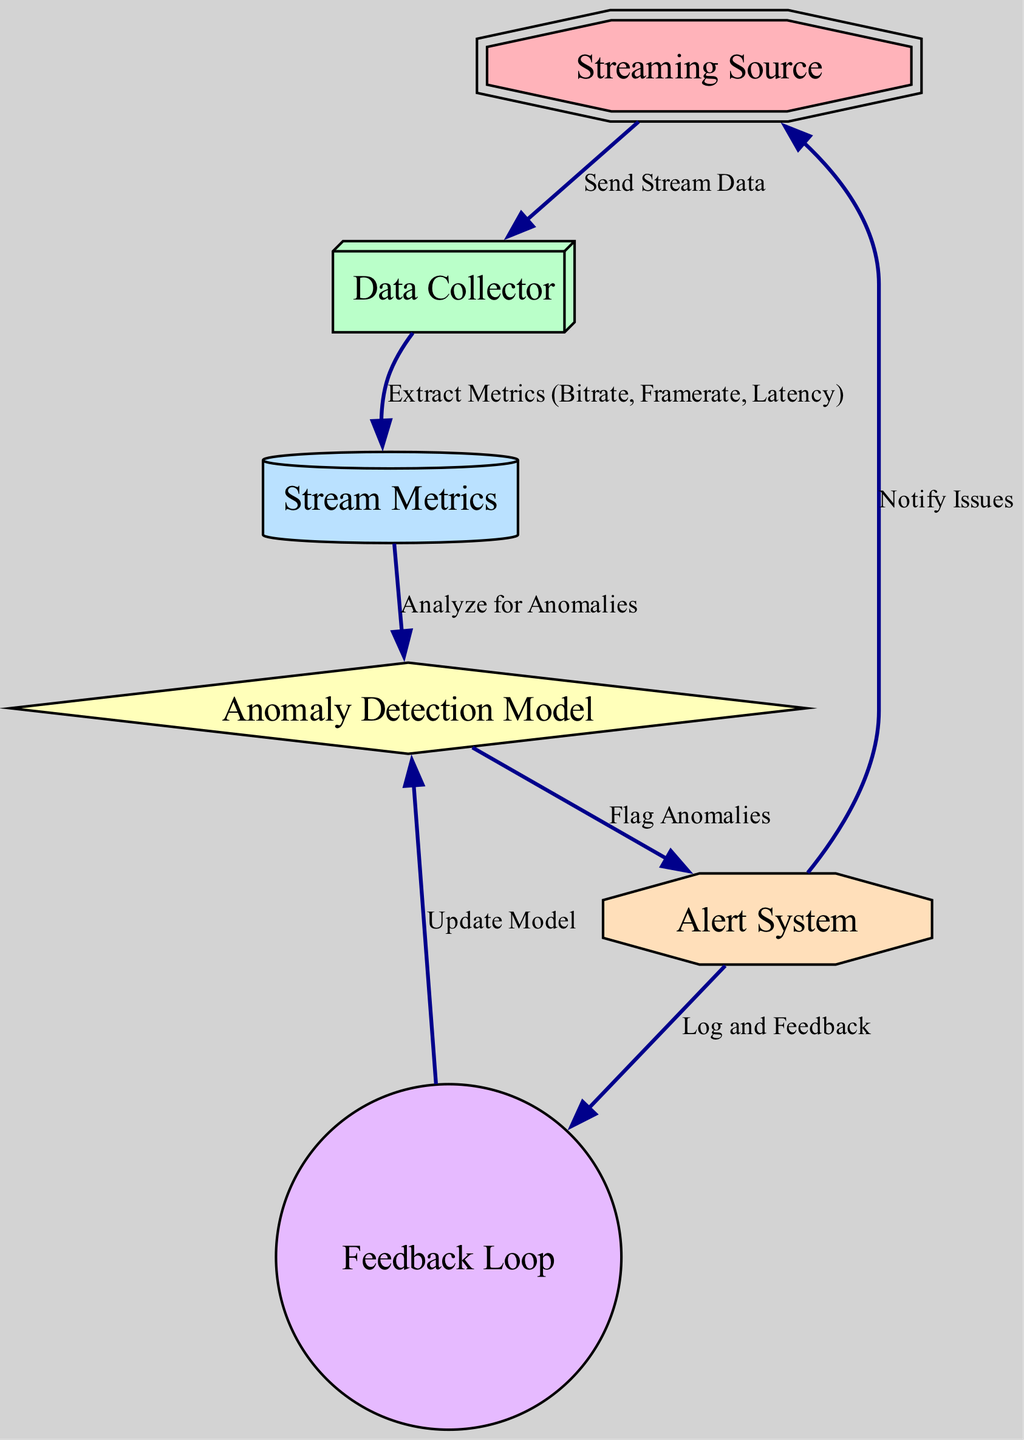What is the first node in the diagram? The first node, indicating the starting point of the process, is labeled "Streaming Source." This can be identified by locating the topmost node in the diagram layout.
Answer: Streaming Source How many nodes are present in the diagram? By counting all individual nodes listed in the diagram, we find six distinct nodes: "Streaming Source," "Data Collector," "Stream Metrics," "Anomaly Detection Model," "Alert System," and "Feedback Loop."
Answer: 6 What label is assigned to the second node? The second node is labeled "Data Collector." This can be determined by sequentially identifying the nodes based on their order in the diagram.
Answer: Data Collector Which node sends stream data? The node that sends stream data, indicated by the edge, is the "Streaming Source." This node has a direct outgoing edge labeled "Send Stream Data" pointing to the "Data Collector."
Answer: Streaming Source What is the final destination node for alerts? The final destination for alerts in the diagram is the "Streaming Source." This can be deduced from the outgoing edge from the "Alert System" node, which is labeled "Notify Issues" and points back to the "Streaming Source."
Answer: Streaming Source How many edges connect the nodes? There are six edges connecting the nodes as shown in the diagram. Each edge indicates the relationship and flow of information between nodes, resulting in a total of 6 connections.
Answer: 6 What does the Feedback Loop node do? The "Feedback Loop" node updates the anomaly detection model, as indicated by the edge labeled "Update Model" pointing from "Feedback Loop" to "Anomaly Detection Model." This shows that information from the feedback loop is used to improve the model.
Answer: Update Model Which node receives alerts? The node that receives alerts is the "Streaming Source." This can be identified from the edge labeled "Notify Issues," which shows an outgoing connection from the "Alert System" back to "Streaming Source."
Answer: Streaming Source What kind of model is being utilized? The model utilized is an "Anomaly Detection Model." This designation can be confirmed by directly inspecting the node labeled as such within the diagram.
Answer: Anomaly Detection Model 